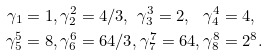<formula> <loc_0><loc_0><loc_500><loc_500>\gamma _ { 1 } & = 1 , \gamma _ { 2 } ^ { 2 } = 4 / 3 , \text { } \gamma _ { 3 } ^ { 3 } = 2 , \text { } \text { } \gamma _ { 4 } ^ { 4 } = 4 , \\ \gamma _ { 5 } ^ { 5 } & = 8 , \gamma _ { 6 } ^ { 6 } = 6 4 / 3 , \gamma _ { 7 } ^ { 7 } = 6 4 , \gamma _ { 8 } ^ { 8 } = 2 ^ { 8 } .</formula> 